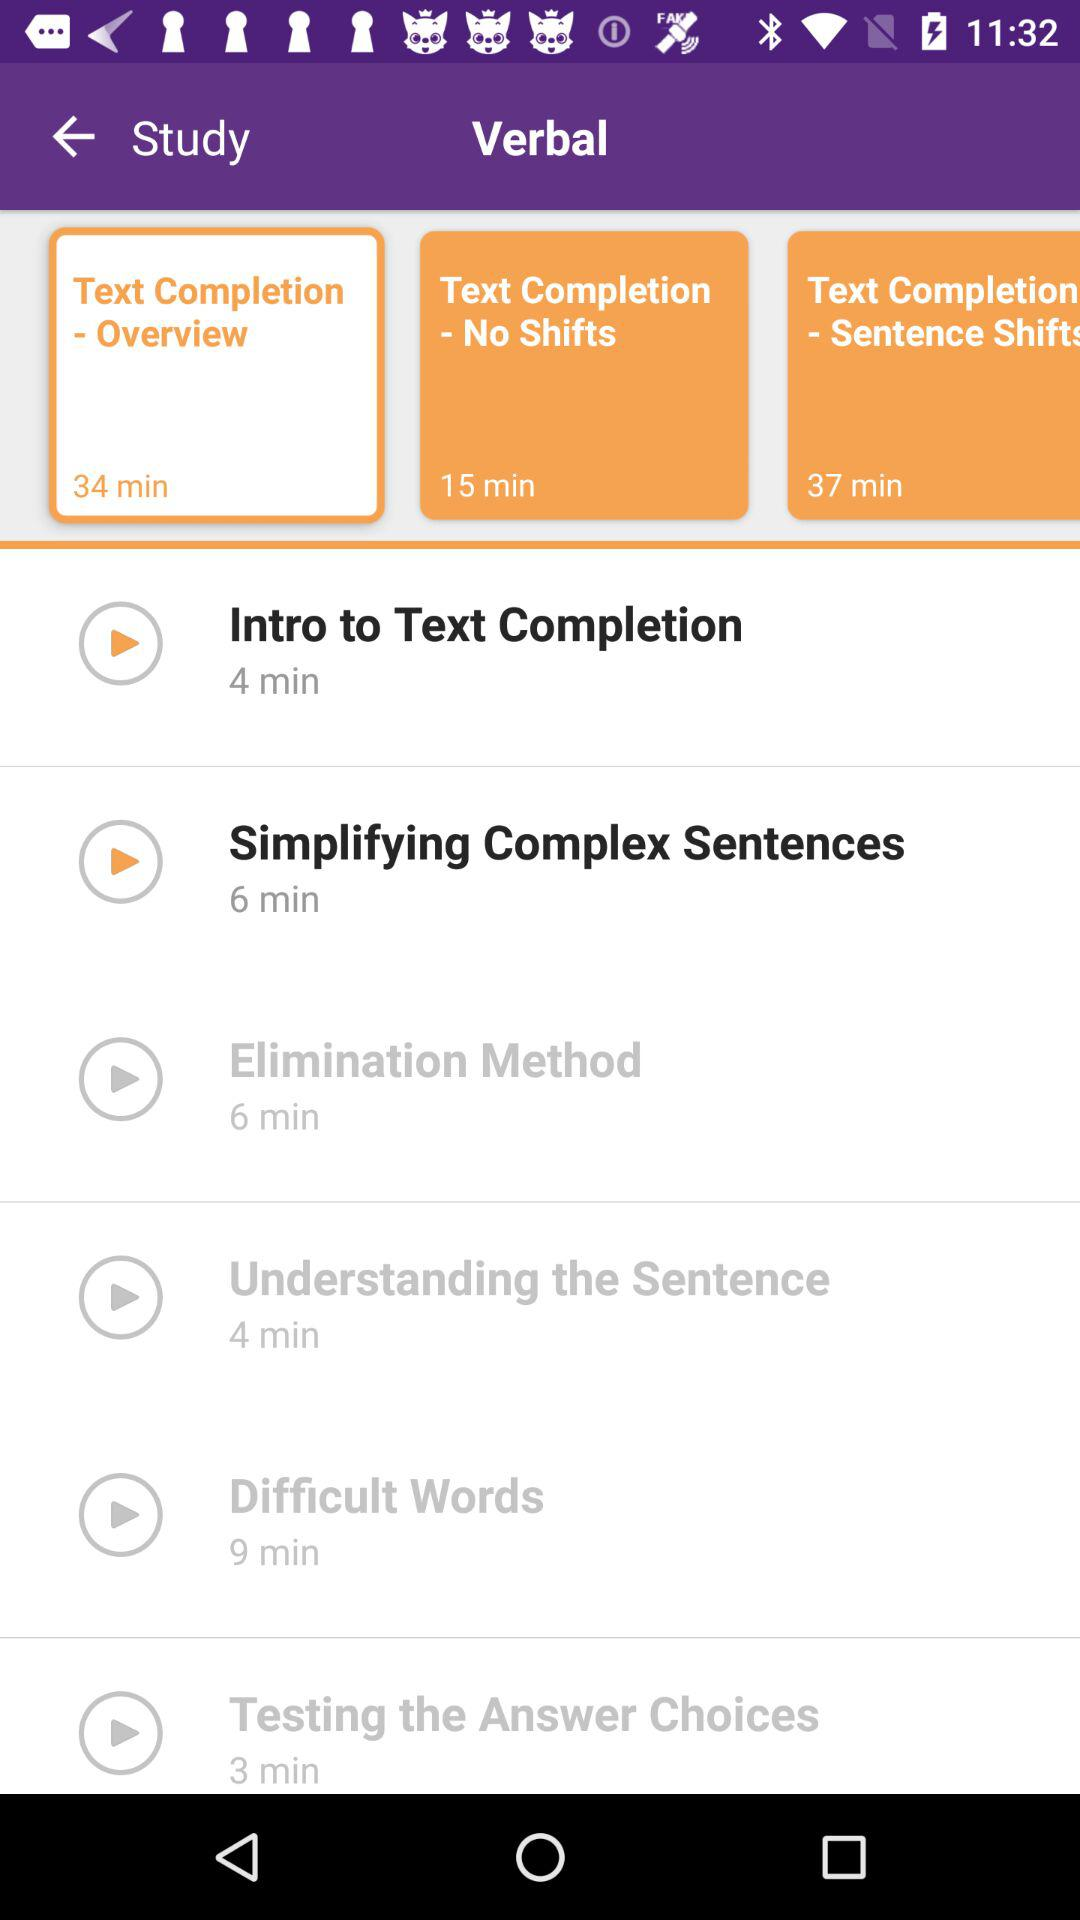What is the duration of the "Elimination Method" video? The duration of the "Elimination Method" video is 6 minutes. 